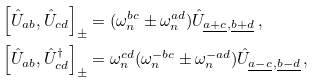<formula> <loc_0><loc_0><loc_500><loc_500>\left [ \hat { U } _ { a b } , \hat { U } _ { c d } \right ] _ { \pm } & = ( \omega _ { n } ^ { b c } \pm \omega _ { n } ^ { a d } ) \hat { U } _ { \underline { a + c } , \underline { b + d } } \, , \\ \left [ \hat { U } _ { a b } , \hat { U } _ { c d } ^ { \dagger } \right ] _ { \pm } & = \omega _ { n } ^ { c d } ( \omega _ { n } ^ { - b c } \pm \omega _ { n } ^ { - a d } ) \hat { U } _ { \underline { a - c } , \underline { b - d } } \, ,</formula> 